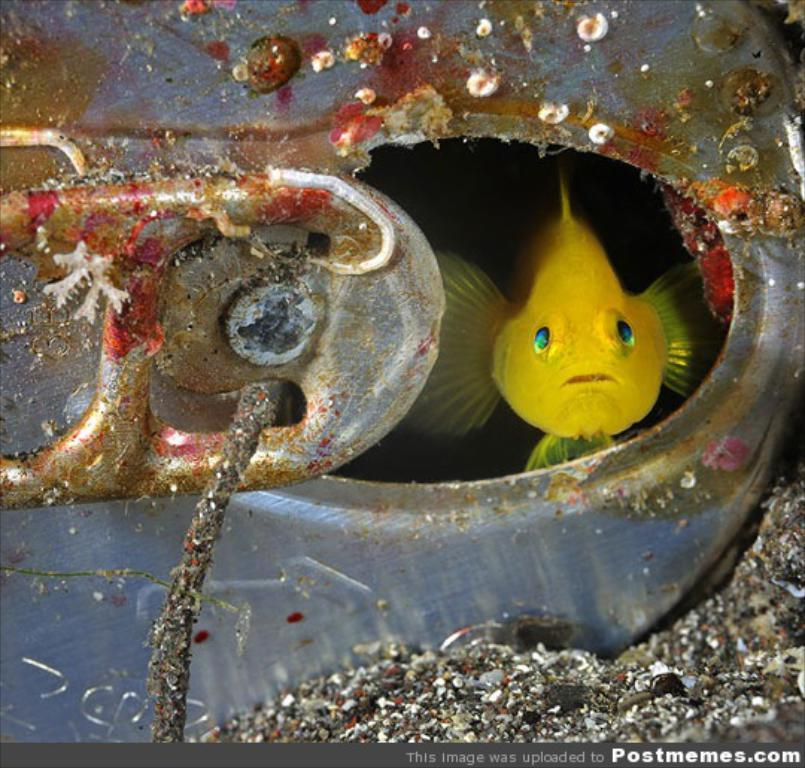What type of animal is in the image? There is a fish in the image. What color is the fish? The fish is yellow in color. What type of bomb can be seen in the image? There is no bomb present in the image; it features a yellow fish. How many beads are visible in the image? There are no beads present in the image. 